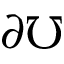Convert formula to latex. <formula><loc_0><loc_0><loc_500><loc_500>\partial \mho</formula> 